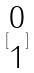<formula> <loc_0><loc_0><loc_500><loc_500>[ \begin{matrix} 0 \\ 1 \end{matrix} ]</formula> 